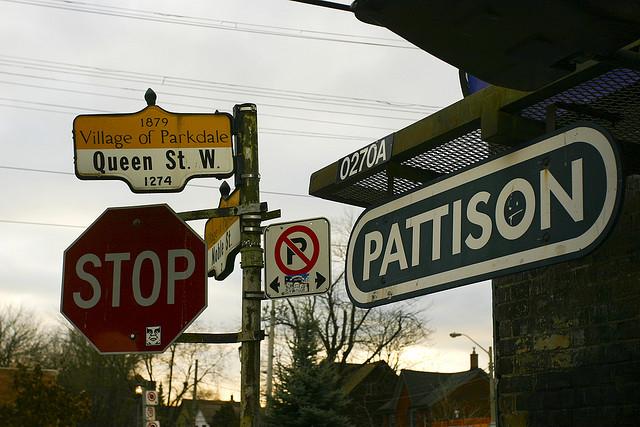Where is the stop sign?
Give a very brief answer. Left. Is there a stop sign?
Concise answer only. Yes. What is the name of the Village?
Be succinct. Parkdale. 